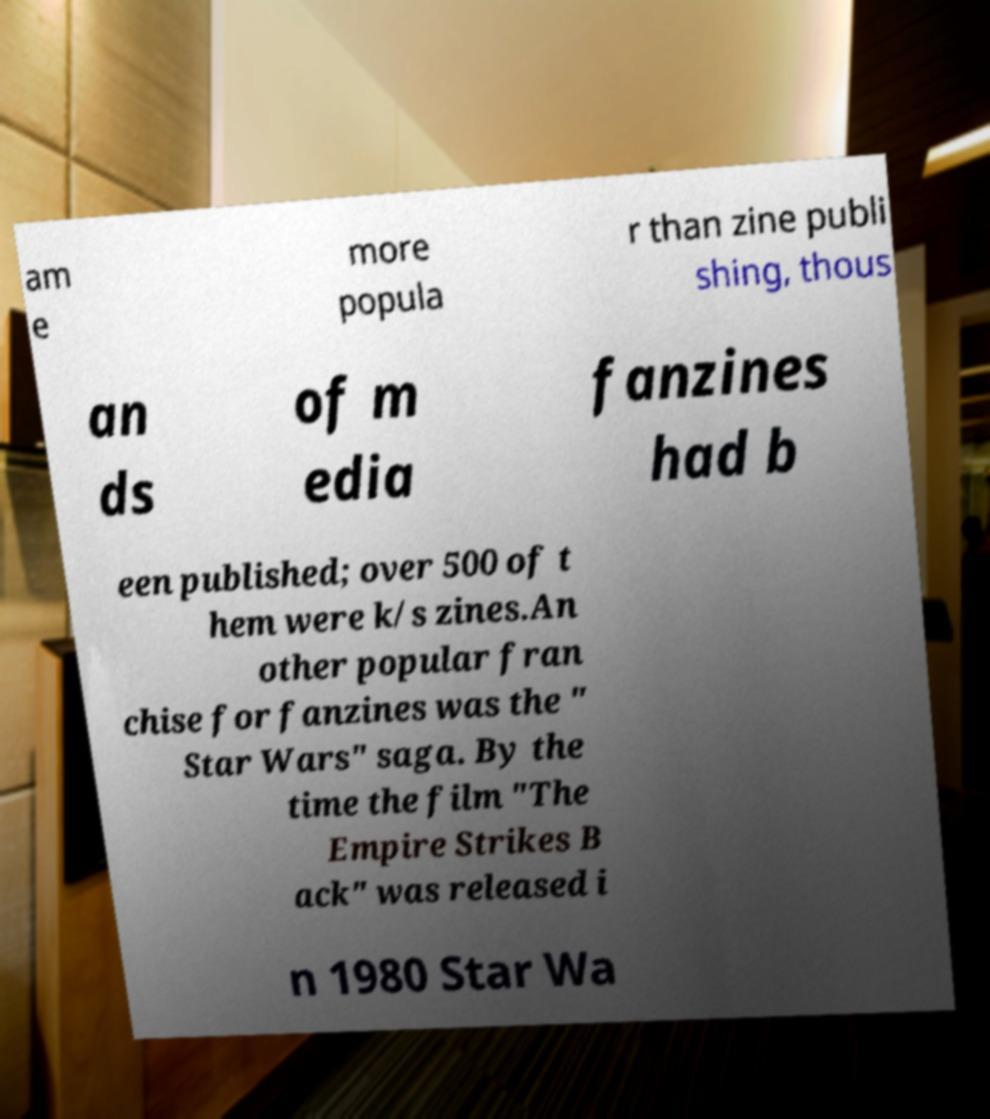I need the written content from this picture converted into text. Can you do that? am e more popula r than zine publi shing, thous an ds of m edia fanzines had b een published; over 500 of t hem were k/s zines.An other popular fran chise for fanzines was the " Star Wars" saga. By the time the film "The Empire Strikes B ack" was released i n 1980 Star Wa 